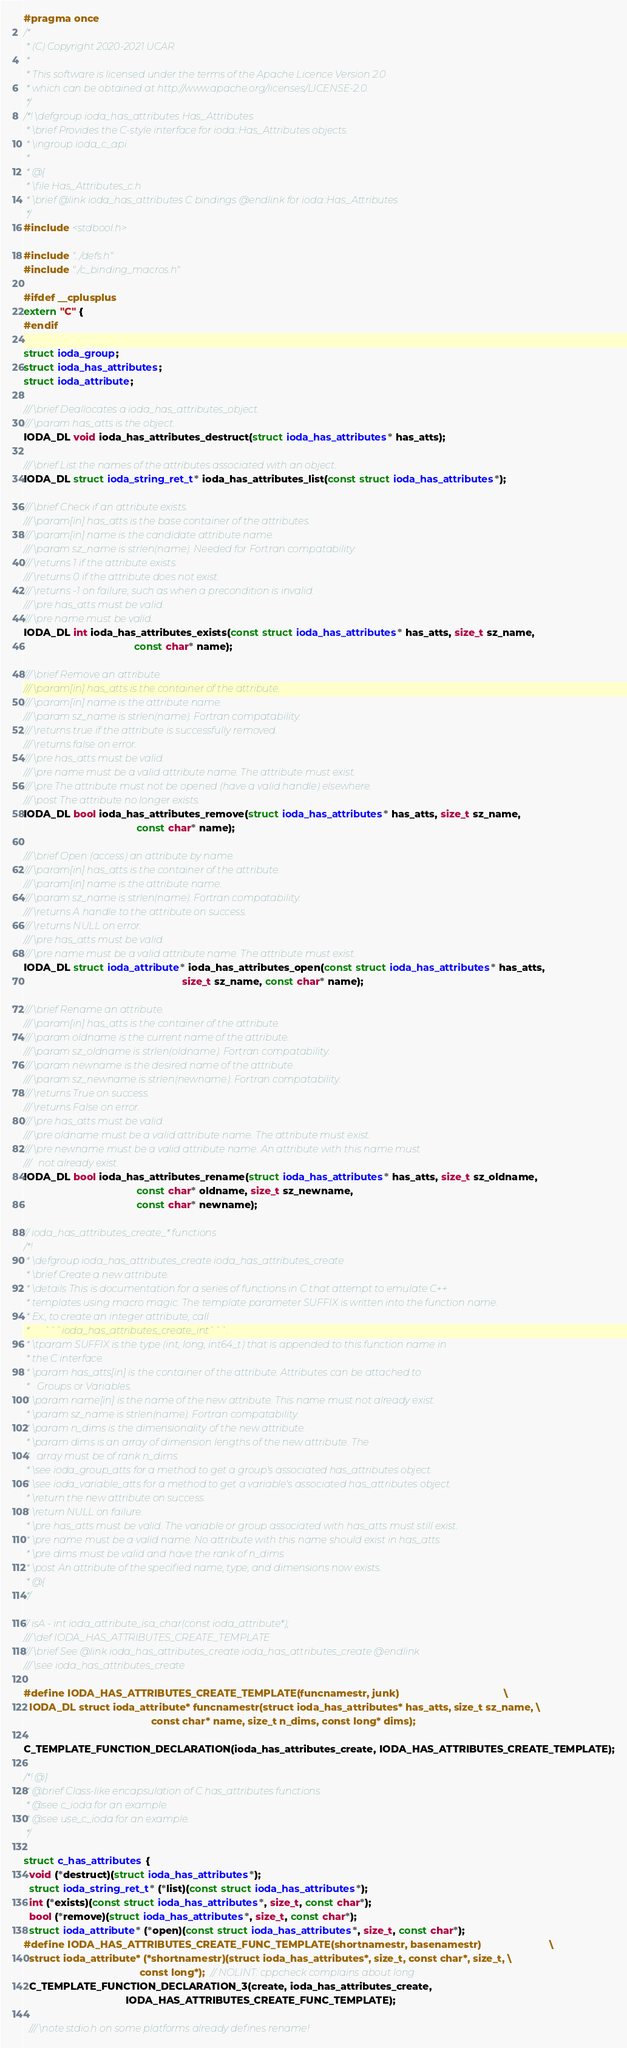<code> <loc_0><loc_0><loc_500><loc_500><_C_>#pragma once
/*
 * (C) Copyright 2020-2021 UCAR
 *
 * This software is licensed under the terms of the Apache Licence Version 2.0
 * which can be obtained at http://www.apache.org/licenses/LICENSE-2.0.
 */
/*! \defgroup ioda_has_attributes Has_Attributes
 * \brief Provides the C-style interface for ioda::Has_Attributes objects.
 * \ingroup ioda_c_api
 *
 * @{
 * \file Has_Attributes_c.h
 * \brief @link ioda_has_attributes C bindings @endlink for ioda::Has_Attributes
 */
#include <stdbool.h>

#include "../defs.h"
#include "./c_binding_macros.h"

#ifdef __cplusplus
extern "C" {
#endif

struct ioda_group;
struct ioda_has_attributes;
struct ioda_attribute;

/// \brief Deallocates a ioda_has_attributes_object.
/// \param has_atts is the object.
IODA_DL void ioda_has_attributes_destruct(struct ioda_has_attributes* has_atts);

/// \brief List the names of the attributes associated with an object.
IODA_DL struct ioda_string_ret_t* ioda_has_attributes_list(const struct ioda_has_attributes*);

/// \brief Check if an attribute exists.
/// \param[in] has_atts is the base container of the attributes.
/// \param[in] name is the candidate attribute name.
/// \param sz_name is strlen(name). Needed for Fortran compatability.
/// \returns 1 if the attribute exists.
/// \returns 0 if the attribute does not exist.
/// \returns -1 on failure, such as when a precondition is invalid.
/// \pre has_atts must be valid.
/// \pre name must be valid.
IODA_DL int ioda_has_attributes_exists(const struct ioda_has_attributes* has_atts, size_t sz_name,
                                       const char* name);

/// \brief Remove an attribute.
/// \param[in] has_atts is the container of the attribute.
/// \param[in] name is the attribute name.
/// \param sz_name is strlen(name). Fortran compatability.
/// \returns true if the attribute is successfully removed.
/// \returns false on error.
/// \pre has_atts must be valid.
/// \pre name must be a valid attribute name. The attribute must exist.
/// \pre The attribute must not be opened (have a valid handle) elsewhere.
/// \post The attribute no longer exists.
IODA_DL bool ioda_has_attributes_remove(struct ioda_has_attributes* has_atts, size_t sz_name,
                                        const char* name);

/// \brief Open (access) an attribute by name.
/// \param[in] has_atts is the container of the attribute.
/// \param[in] name is the attribute name.
/// \param sz_name is strlen(name). Fortran compatability.
/// \returns A handle to the attribute on success.
/// \returns NULL on error.
/// \pre has_atts must be valid.
/// \pre name must be a valid attribute name. The attribute must exist.
IODA_DL struct ioda_attribute* ioda_has_attributes_open(const struct ioda_has_attributes* has_atts,
                                                        size_t sz_name, const char* name);

/// \brief Rename an attribute.
/// \param[in] has_atts is the container of the attribute.
/// \param oldname is the current name of the attribute.
/// \param sz_oldname is strlen(oldname). Fortran compatability.
/// \param newname is the desired name of the attribute.
/// \param sz_newname is strlen(newname). Fortran compatability.
/// \returns True on success.
/// \returns False on error.
/// \pre has_atts must be valid.
/// \pre oldname must be a valid attribute name. The attribute must exist.
/// \pre newname must be a valid attribute name. An attribute with this name must
///   not already exist.
IODA_DL bool ioda_has_attributes_rename(struct ioda_has_attributes* has_atts, size_t sz_oldname,
                                        const char* oldname, size_t sz_newname,
                                        const char* newname);

// ioda_has_attributes_create_* functions
/*!
 * \defgroup ioda_has_attributes_create ioda_has_attributes_create
 * \brief Create a new attribute.
 * \details This is documentation for a series of functions in C that attempt to emulate C++
 * templates using macro magic. The template parameter SUFFIX is written into the function name.
 * Ex:, to create an integer attribute, call
 *      ```ioda_has_attributes_create_int```.
 * \tparam SUFFIX is the type (int, long, int64_t) that is appended to this function name in
 * the C interface.
 * \param has_atts[in] is the container of the attribute. Attributes can be attached to
 *   Groups or Variables.
 * \param name[in] is the name of the new attribute. This name must not already exist.
 * \param sz_name is strlen(name). Fortran compatability.
 * \param n_dims is the dimensionality of the new attribute.
 * \param dims is an array of dimension lengths of the new attribute. The
 *   array must be of rank n_dims.
 * \see ioda_group_atts for a method to get a group's associated has_attributes object.
 * \see ioda_variable_atts for a method to get a variable's associated has_attributes object.
 * \return the new attribute on success.
 * \return NULL on failure.
 * \pre has_atts must be valid. The variable or group associated with has_atts must still exist.
 * \pre name must be a valid name. No attribute with this name should exist in has_atts.
 * \pre dims must be valid and have the rank of n_dims.
 * \post An attribute of the specified name, type, and dimensions now exists.
 * @{
 */

// isA - int ioda_attribute_isa_char(const ioda_attribute*);
/// \def IODA_HAS_ATTRIBUTES_CREATE_TEMPLATE
/// \brief See @link ioda_has_attributes_create ioda_has_attributes_create @endlink
/// \see ioda_has_attributes_create

#define IODA_HAS_ATTRIBUTES_CREATE_TEMPLATE(funcnamestr, junk)                                     \
  IODA_DL struct ioda_attribute* funcnamestr(struct ioda_has_attributes* has_atts, size_t sz_name, \
                                             const char* name, size_t n_dims, const long* dims);

C_TEMPLATE_FUNCTION_DECLARATION(ioda_has_attributes_create, IODA_HAS_ATTRIBUTES_CREATE_TEMPLATE);

/*! @}
 * @brief Class-like encapsulation of C has_attributes functions.
 * @see c_ioda for an example.
 * @see use_c_ioda for an example.
 */

struct c_has_attributes {
  void (*destruct)(struct ioda_has_attributes*);
  struct ioda_string_ret_t* (*list)(const struct ioda_has_attributes*);
  int (*exists)(const struct ioda_has_attributes*, size_t, const char*);
  bool (*remove)(struct ioda_has_attributes*, size_t, const char*);
  struct ioda_attribute* (*open)(const struct ioda_has_attributes*, size_t, const char*);
#define IODA_HAS_ATTRIBUTES_CREATE_FUNC_TEMPLATE(shortnamestr, basenamestr)                        \
  struct ioda_attribute* (*shortnamestr)(struct ioda_has_attributes*, size_t, const char*, size_t, \
                                         const long*);  // NOLINT: cppcheck complains about long
  C_TEMPLATE_FUNCTION_DECLARATION_3(create, ioda_has_attributes_create,
                                    IODA_HAS_ATTRIBUTES_CREATE_FUNC_TEMPLATE);

  /// \note stdio.h on some platforms already defines rename!</code> 